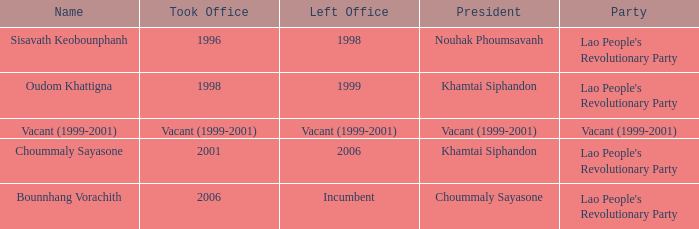What is the party when the name is oudom khattigna? Lao People's Revolutionary Party. Would you mind parsing the complete table? {'header': ['Name', 'Took Office', 'Left Office', 'President', 'Party'], 'rows': [['Sisavath Keobounphanh', '1996', '1998', 'Nouhak Phoumsavanh', "Lao People's Revolutionary Party"], ['Oudom Khattigna', '1998', '1999', 'Khamtai Siphandon', "Lao People's Revolutionary Party"], ['Vacant (1999-2001)', 'Vacant (1999-2001)', 'Vacant (1999-2001)', 'Vacant (1999-2001)', 'Vacant (1999-2001)'], ['Choummaly Sayasone', '2001', '2006', 'Khamtai Siphandon', "Lao People's Revolutionary Party"], ['Bounnhang Vorachith', '2006', 'Incumbent', 'Choummaly Sayasone', "Lao People's Revolutionary Party"]]} 